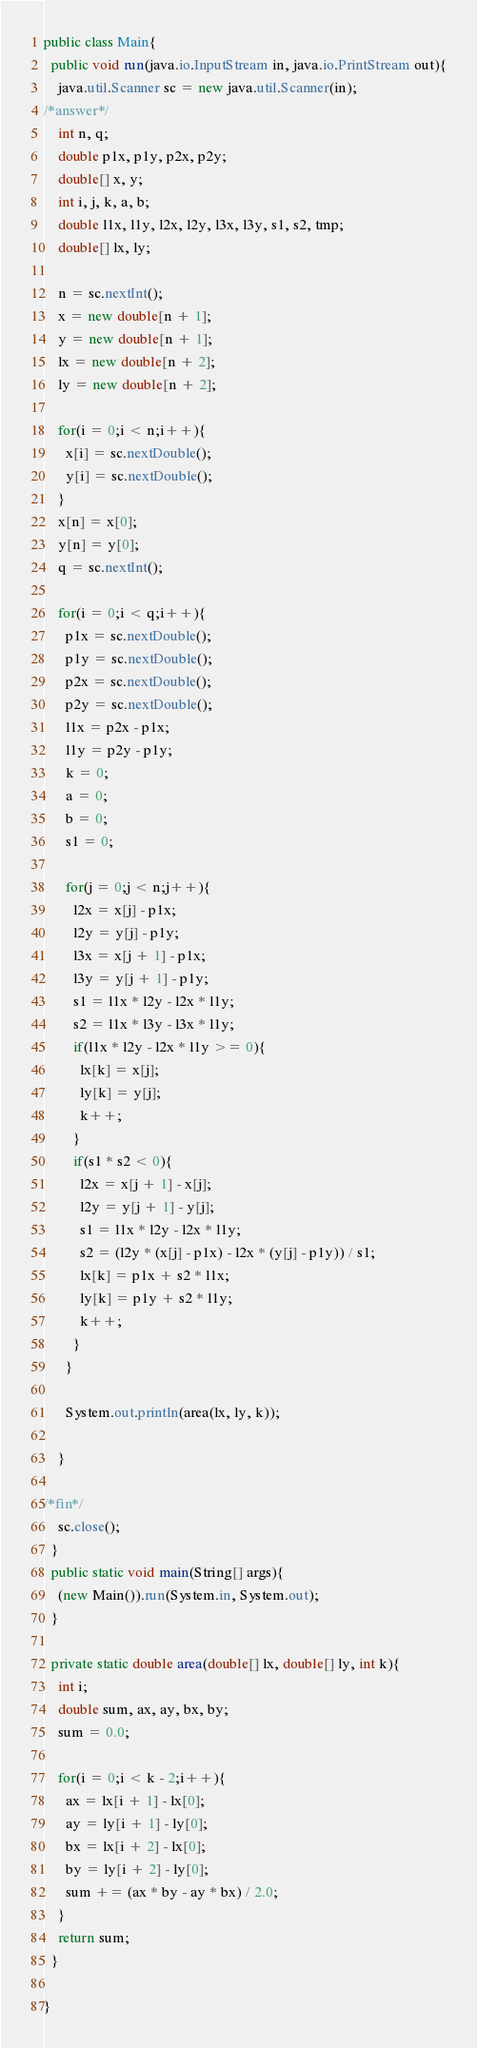<code> <loc_0><loc_0><loc_500><loc_500><_Java_>public class Main{
  public void run(java.io.InputStream in, java.io.PrintStream out){
    java.util.Scanner sc = new java.util.Scanner(in);
/*answer*/
    int n, q;
    double p1x, p1y, p2x, p2y;
    double[] x, y;
    int i, j, k, a, b;
    double l1x, l1y, l2x, l2y, l3x, l3y, s1, s2, tmp;
    double[] lx, ly;

    n = sc.nextInt();
    x = new double[n + 1];
    y = new double[n + 1];
    lx = new double[n + 2];
    ly = new double[n + 2];

    for(i = 0;i < n;i++){
      x[i] = sc.nextDouble();
      y[i] = sc.nextDouble();
    }
    x[n] = x[0];
    y[n] = y[0];
    q = sc.nextInt();

    for(i = 0;i < q;i++){
      p1x = sc.nextDouble();
      p1y = sc.nextDouble();
      p2x = sc.nextDouble();
      p2y = sc.nextDouble();
      l1x = p2x - p1x;
      l1y = p2y - p1y;
      k = 0;
      a = 0;
      b = 0;
      s1 = 0;

      for(j = 0;j < n;j++){
        l2x = x[j] - p1x;
        l2y = y[j] - p1y;
        l3x = x[j + 1] - p1x;
        l3y = y[j + 1] - p1y;
        s1 = l1x * l2y - l2x * l1y;
        s2 = l1x * l3y - l3x * l1y;
        if(l1x * l2y - l2x * l1y >= 0){
          lx[k] = x[j];
          ly[k] = y[j];
          k++;
        }
        if(s1 * s2 < 0){
          l2x = x[j + 1] - x[j];
          l2y = y[j + 1] - y[j];
          s1 = l1x * l2y - l2x * l1y;
          s2 = (l2y * (x[j] - p1x) - l2x * (y[j] - p1y)) / s1;
          lx[k] = p1x + s2 * l1x;
          ly[k] = p1y + s2 * l1y;
          k++;
        }
      }

      System.out.println(area(lx, ly, k));

    }

/*fin*/
    sc.close();
  }
  public static void main(String[] args){
    (new Main()).run(System.in, System.out);
  }

  private static double area(double[] lx, double[] ly, int k){
    int i;
    double sum, ax, ay, bx, by;
    sum = 0.0;

    for(i = 0;i < k - 2;i++){
      ax = lx[i + 1] - lx[0];
      ay = ly[i + 1] - ly[0];
      bx = lx[i + 2] - lx[0];
      by = ly[i + 2] - ly[0];
      sum += (ax * by - ay * bx) / 2.0;
    }
    return sum;
  }

}</code> 